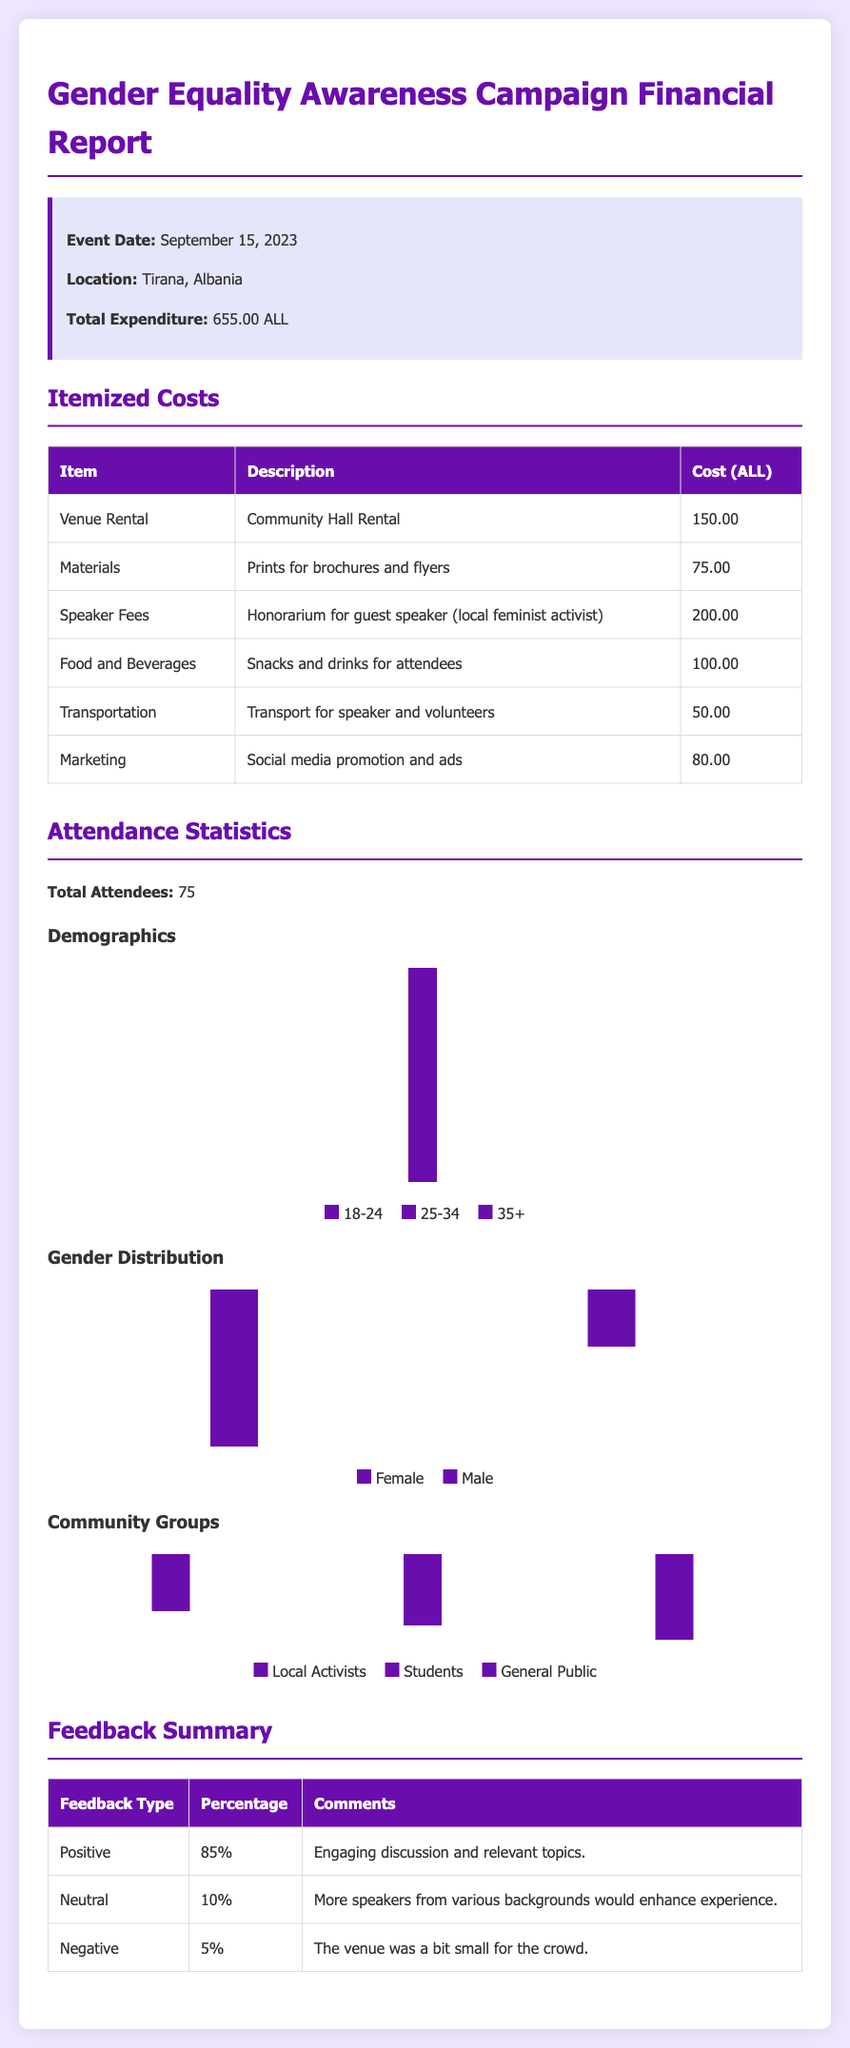What was the total expenditure for the event? The total expenditure is clearly stated in the event info section of the document, which shows the total as 655.00 ALL.
Answer: 655.00 ALL How much was spent on speaker fees? The costs table lists speaker fees as 200.00 ALL, which directly answers the question.
Answer: 200.00 ALL What was the main demographic group in attendance? The attendance statistics indicate that the largest group was 25-34 year-olds, with 30 attendees in that category.
Answer: 25-34 What percentage of feedback received was positive? The feedback summary shows that 85% of the comments were positive, which is the answer to the question.
Answer: 85% What type of event was held on September 15, 2023? The title of the report specifies that it was a Gender Equality Awareness Campaign event, giving us the type of event.
Answer: Gender Equality Awareness Campaign How many total attendees were recorded at the event? The attendance statistics section states that there were 75 total attendees at the event, which is the answer.
Answer: 75 What was the cost for marketing the event? The itemized costs section of the report lists marketing costs as 80.00 ALL, which answers the question.
Answer: 80.00 ALL What was the feedback percentage that was negative? The feedback summary shows that only 5% of the feedback was negative, which is the answer to the question.
Answer: 5% Which demographic group had the least attendees? Analyzing the demographic chart, the 35+ age group had the least attendees at 20, making it the answer.
Answer: 35+ 